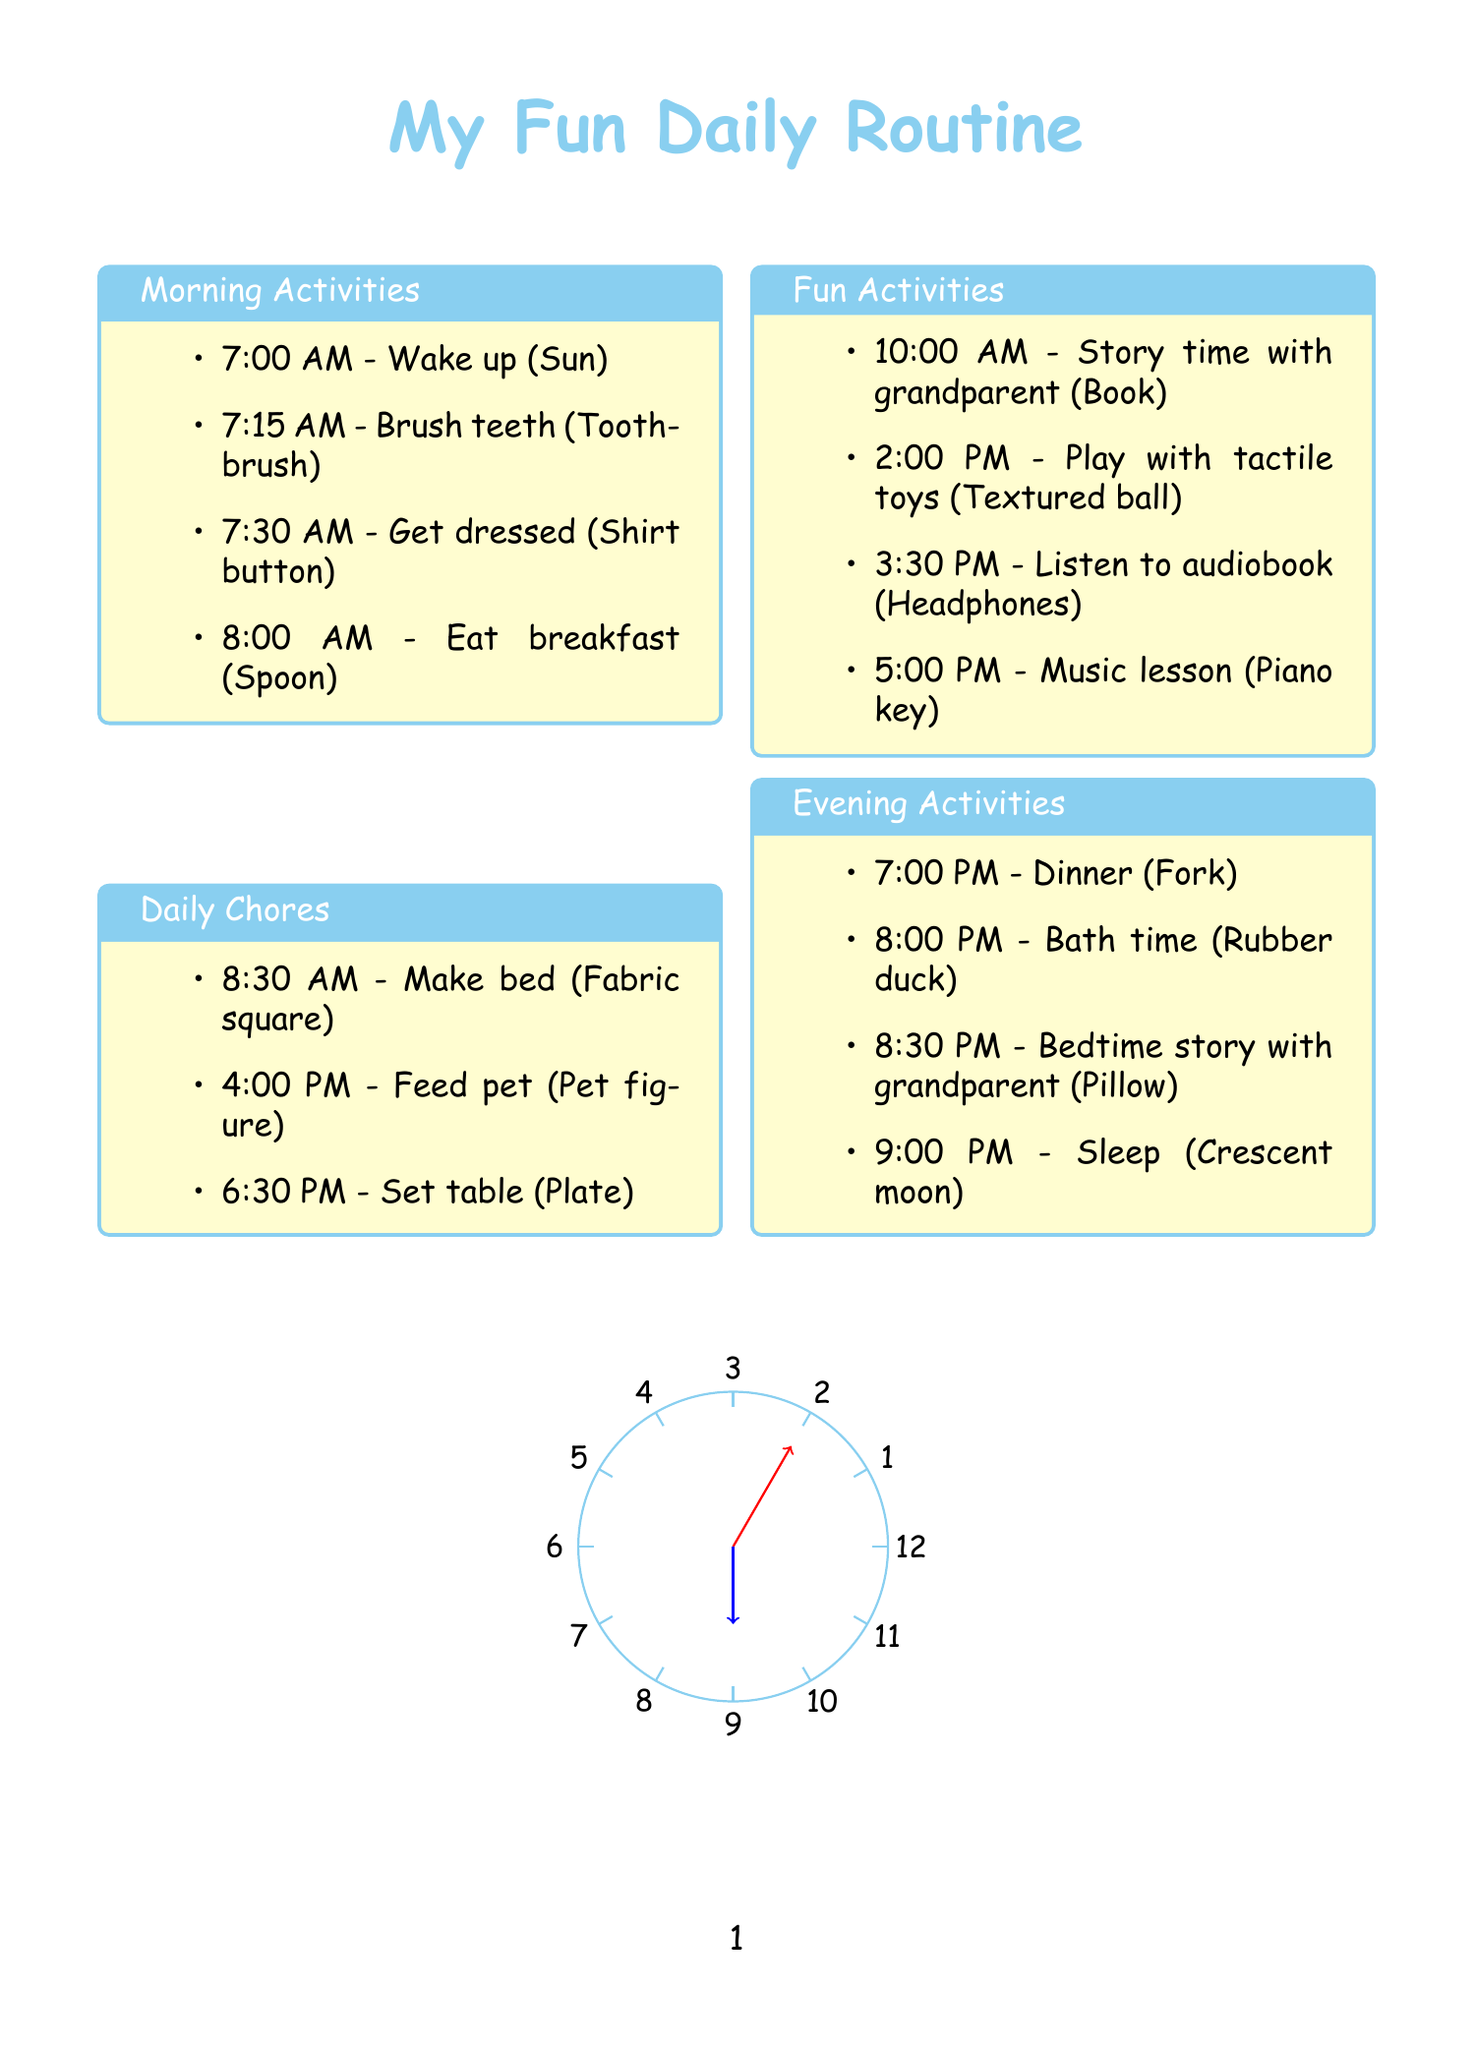What time do you wake up? The wake-up time is the first activity listed in the morning activities section of the document.
Answer: 7:00 AM What is the tactile element for brushing teeth? The tactile element is specifically associated with the activity of brushing teeth, which helps indicate that task.
Answer: Miniature toothbrush What activity occurs right after breakfast? The activity immediately following breakfast can be found in the daily chores section and provides a smooth transition from meals to responsibilities.
Answer: Make bed How many fun activities are listed? This can be determined by counting the number of items in the fun activities section of the document.
Answer: Four What is the last activity of the day? The last activity is mentioned in the evening activities section and concludes the daily routine.
Answer: Sleep Which activity includes a plastic fork? This question refers to the specific dinner activity outlined in the evening activities section, which uses that particular tactile element.
Answer: Dinner What is the tactile element associated with story time? The tactile element is designated for the activity of story time, helping to identify it within the document.
Answer: Small book shape What time do you play with tactile toys? The time for this specific fun activity is documented clearly, providing an exact moment for the activity.
Answer: 2:00 PM 